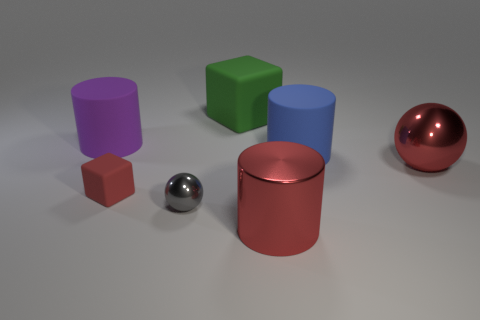Subtract all blue cylinders. How many cylinders are left? 2 Add 1 small shiny balls. How many objects exist? 8 Subtract all cylinders. How many objects are left? 4 Add 4 large blue things. How many large blue things are left? 5 Add 6 small cubes. How many small cubes exist? 7 Subtract 1 red balls. How many objects are left? 6 Subtract all red things. Subtract all small green rubber spheres. How many objects are left? 4 